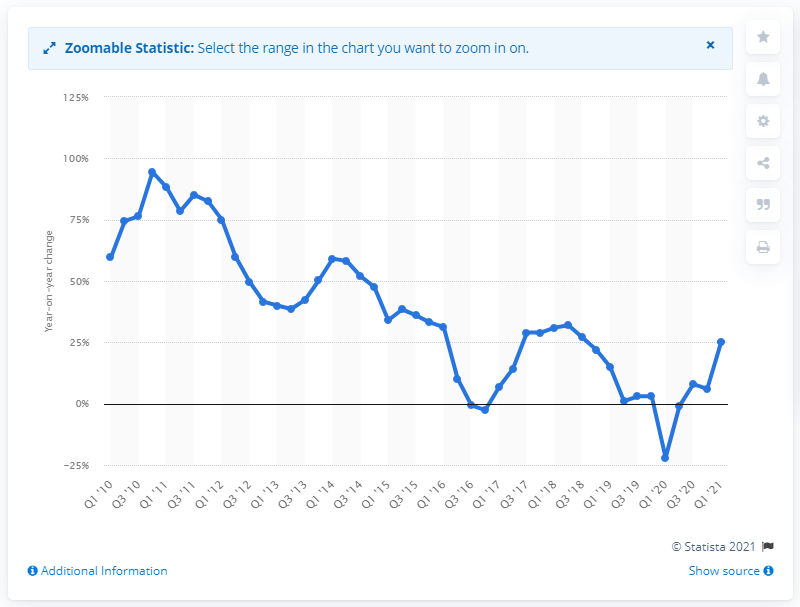Indicate a few pertinent items in this graphic. Baidu's revenue increased by 25% in the most recent quarter. 